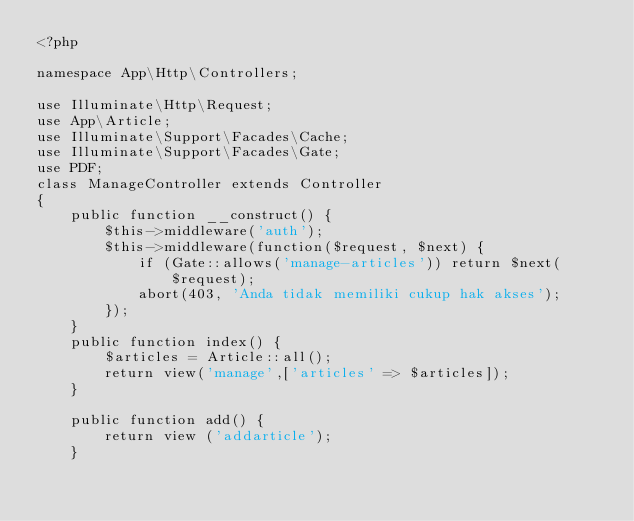Convert code to text. <code><loc_0><loc_0><loc_500><loc_500><_PHP_><?php

namespace App\Http\Controllers;

use Illuminate\Http\Request;
use App\Article;
use Illuminate\Support\Facades\Cache;
use Illuminate\Support\Facades\Gate;
use PDF;
class ManageController extends Controller
{
    public function __construct() {
        $this->middleware('auth');
        $this->middleware(function($request, $next) {
            if (Gate::allows('manage-articles')) return $next($request);
            abort(403, 'Anda tidak memiliki cukup hak akses');
        });
    }
    public function index() {
        $articles = Article::all();
        return view('manage',['articles' => $articles]);
    }

    public function add() {
        return view ('addarticle');
    }
</code> 